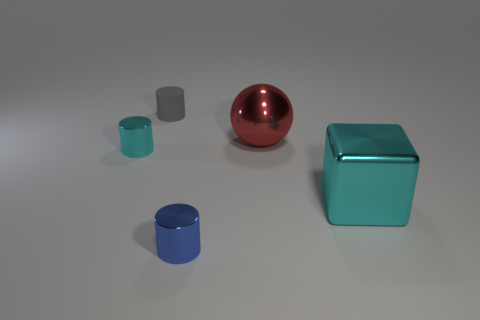What shape is the tiny metallic thing that is the same color as the big metallic block?
Keep it short and to the point. Cylinder. Is there a big brown sphere that has the same material as the gray object?
Provide a succinct answer. No. There is a red metallic thing; what shape is it?
Your response must be concise. Sphere. How many metallic objects are there?
Your answer should be very brief. 4. There is a shiny cylinder in front of the thing that is on the right side of the large red sphere; what color is it?
Your answer should be compact. Blue. What color is the shiny thing that is the same size as the cube?
Ensure brevity in your answer.  Red. Are there any cubes of the same color as the ball?
Provide a short and direct response. No. Is there a large red metallic object?
Your response must be concise. Yes. What is the shape of the small thing right of the gray object?
Your answer should be compact. Cylinder. How many cylinders are in front of the small rubber cylinder and on the left side of the tiny blue metal object?
Your response must be concise. 1. 